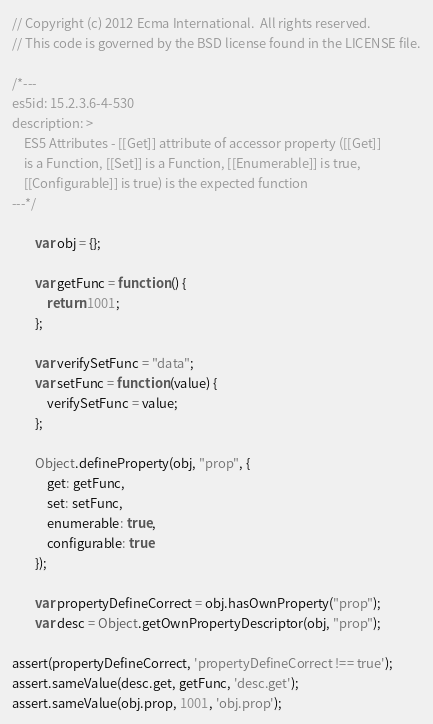<code> <loc_0><loc_0><loc_500><loc_500><_JavaScript_>// Copyright (c) 2012 Ecma International.  All rights reserved.
// This code is governed by the BSD license found in the LICENSE file.

/*---
es5id: 15.2.3.6-4-530
description: >
    ES5 Attributes - [[Get]] attribute of accessor property ([[Get]]
    is a Function, [[Set]] is a Function, [[Enumerable]] is true,
    [[Configurable]] is true) is the expected function
---*/

        var obj = {};

        var getFunc = function () {
            return 1001;
        };

        var verifySetFunc = "data";
        var setFunc = function (value) {
            verifySetFunc = value;
        };

        Object.defineProperty(obj, "prop", {
            get: getFunc,
            set: setFunc,
            enumerable: true,
            configurable: true
        });

        var propertyDefineCorrect = obj.hasOwnProperty("prop");
        var desc = Object.getOwnPropertyDescriptor(obj, "prop");

assert(propertyDefineCorrect, 'propertyDefineCorrect !== true');
assert.sameValue(desc.get, getFunc, 'desc.get');
assert.sameValue(obj.prop, 1001, 'obj.prop');
</code> 